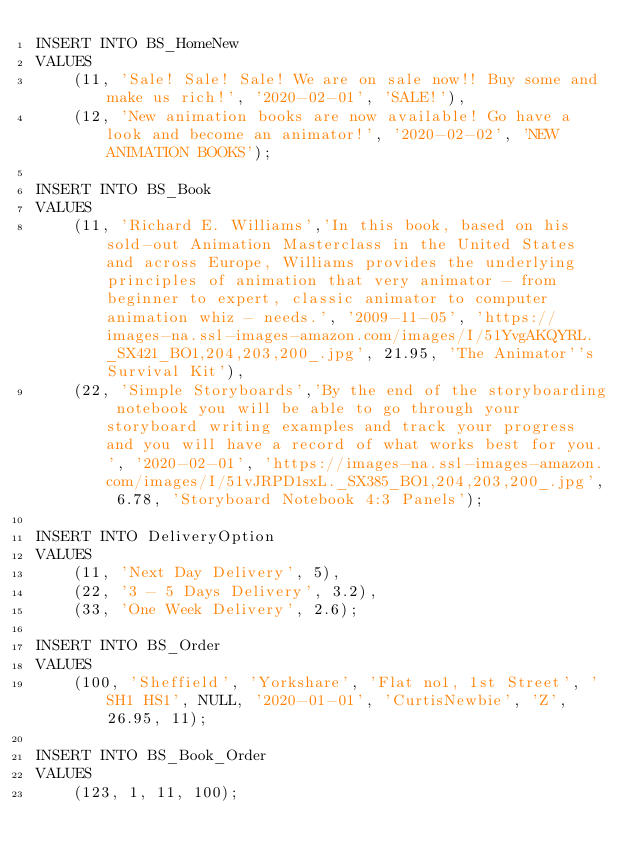<code> <loc_0><loc_0><loc_500><loc_500><_SQL_>INSERT INTO BS_HomeNew 
VALUES 
    (11, 'Sale! Sale! Sale! We are on sale now!! Buy some and make us rich!', '2020-02-01', 'SALE!'),
    (12, 'New animation books are now available! Go have a look and become an animator!', '2020-02-02', 'NEW ANIMATION BOOKS');

INSERT INTO BS_Book 
VALUES 
    (11, 'Richard E. Williams','In this book, based on his sold-out Animation Masterclass in the United States and across Europe, Williams provides the underlying principles of animation that very animator - from beginner to expert, classic animator to computer animation whiz - needs.', '2009-11-05', 'https://images-na.ssl-images-amazon.com/images/I/51YvgAKQYRL._SX421_BO1,204,203,200_.jpg', 21.95, 'The Animator''s Survival Kit'),
    (22, 'Simple Storyboards','By the end of the storyboarding notebook you will be able to go through your storyboard writing examples and track your progress and you will have a record of what works best for you.', '2020-02-01', 'https://images-na.ssl-images-amazon.com/images/I/51vJRPD1sxL._SX385_BO1,204,203,200_.jpg', 6.78, 'Storyboard Notebook 4:3 Panels');

INSERT INTO DeliveryOption
VALUES
    (11, 'Next Day Delivery', 5),
    (22, '3 - 5 Days Delivery', 3.2),
    (33, 'One Week Delivery', 2.6);

INSERT INTO BS_Order
VALUES
    (100, 'Sheffield', 'Yorkshare', 'Flat no1, 1st Street', 'SH1 HS1', NULL, '2020-01-01', 'CurtisNewbie', 'Z', 26.95, 11);

INSERT INTO BS_Book_Order
VALUES
    (123, 1, 11, 100);
</code> 